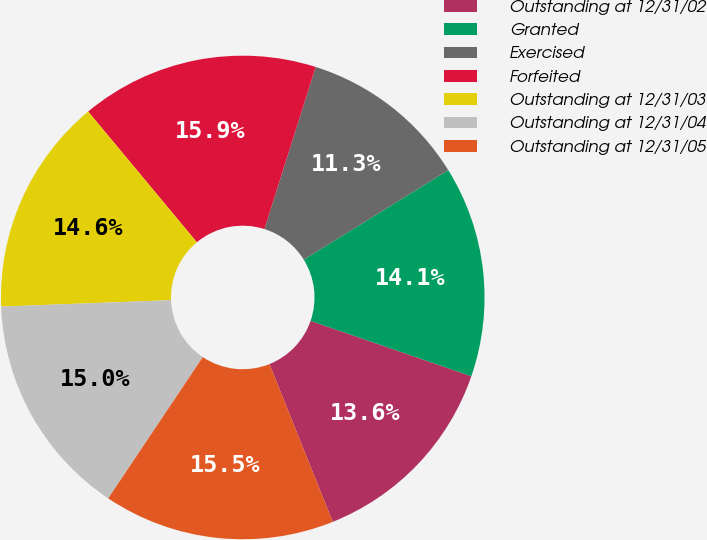<chart> <loc_0><loc_0><loc_500><loc_500><pie_chart><fcel>Outstanding at 12/31/02<fcel>Granted<fcel>Exercised<fcel>Forfeited<fcel>Outstanding at 12/31/03<fcel>Outstanding at 12/31/04<fcel>Outstanding at 12/31/05<nl><fcel>13.65%<fcel>14.11%<fcel>11.29%<fcel>15.92%<fcel>14.56%<fcel>15.01%<fcel>15.46%<nl></chart> 